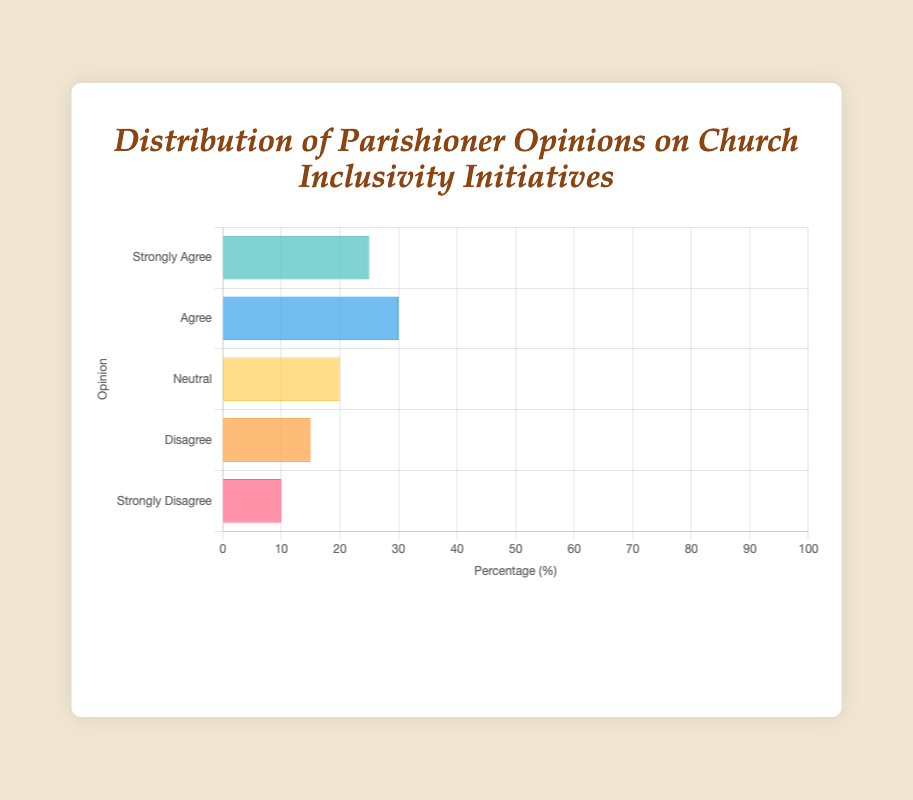what percentage of parishioners either Strongly Agree or Agree with the Church inclusivity initiatives? Sum the percentage of parishioners who Strongly Agree (25%) and Agree (30%). 25 + 30 = 55
Answer: 55 which opinion category has the lowest percentage of parishioners? Compare all the percentage values and identify the lowest one, which is 10% for Strongly Disagree
Answer: Strongly Disagree how do the opinions of Neutral parishioners compare to those who Disagree? Compare their percentages: Neutral (20%) and Disagree (15%). Neutral is higher than Disagree by 5%.
Answer: Neutral is higher if you add the percentages of those who Disagree and those who Strongly Disagree, what is the result? Add the percentage of Disagree (15%) and Strongly Disagree (10%). 15 + 10 = 25
Answer: 25 what is the combined percentage of parishioners who do not have a strong opinion either way (Neutral, Disagree, and Strongly Disagree)? Sum the percentages of Neutral (20%), Disagree (15%), and Strongly Disagree (10%). 20 + 15 + 10 = 45
Answer: 45 which color represents the bar for the 'Agree' opinion? By observing the bar colors, the 'Agree' opinion is represented by the blue bar.
Answer: blue what is the difference in percentage between Strongly Agree and Strongly Disagree opinions? Subtract the percentage of Strongly Disagree (10%) from Strongly Agree (25%). 25 - 10 = 15
Answer: 15 are the opinions of Neutral parishioners closer to Strongly Agree or Disagree parishioners? Compare the percentage differences: Neutral (20%) to Strongly Agree (25% - 20% = 5%) and Neutral (20%) to Disagree (20% - 15% = 5%). Both differences are equal.
Answer: equally close how does the percentage of parishioners who Agree compare to the percentage of those who Strongly Agree? Compare percentages: Agree (30%) and Strongly Agree (25%), Agree is higher by 5%.
Answer: Agree is higher which opinion makes up one-fourth of the parishioner opinions? Identify one-fourth of 100%: 100 / 4 = 25%. The opinion with 25% is Strongly Agree.
Answer: Strongly Agree 